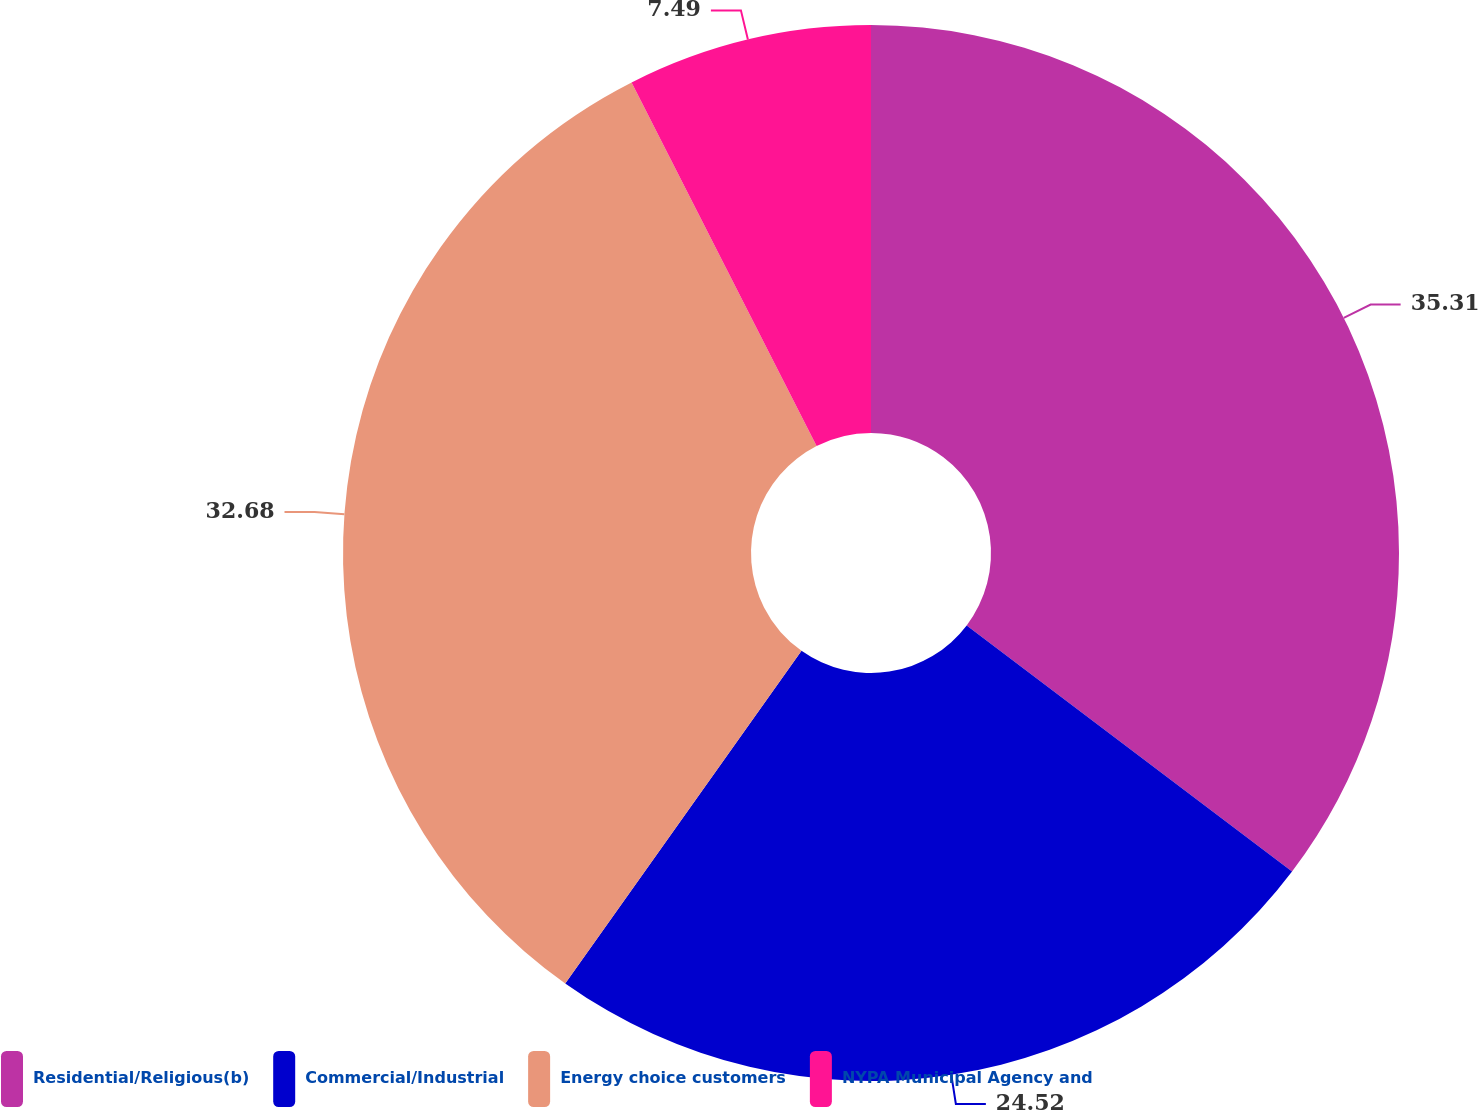Convert chart to OTSL. <chart><loc_0><loc_0><loc_500><loc_500><pie_chart><fcel>Residential/Religious(b)<fcel>Commercial/Industrial<fcel>Energy choice customers<fcel>NYPA Municipal Agency and<nl><fcel>35.31%<fcel>24.52%<fcel>32.68%<fcel>7.49%<nl></chart> 